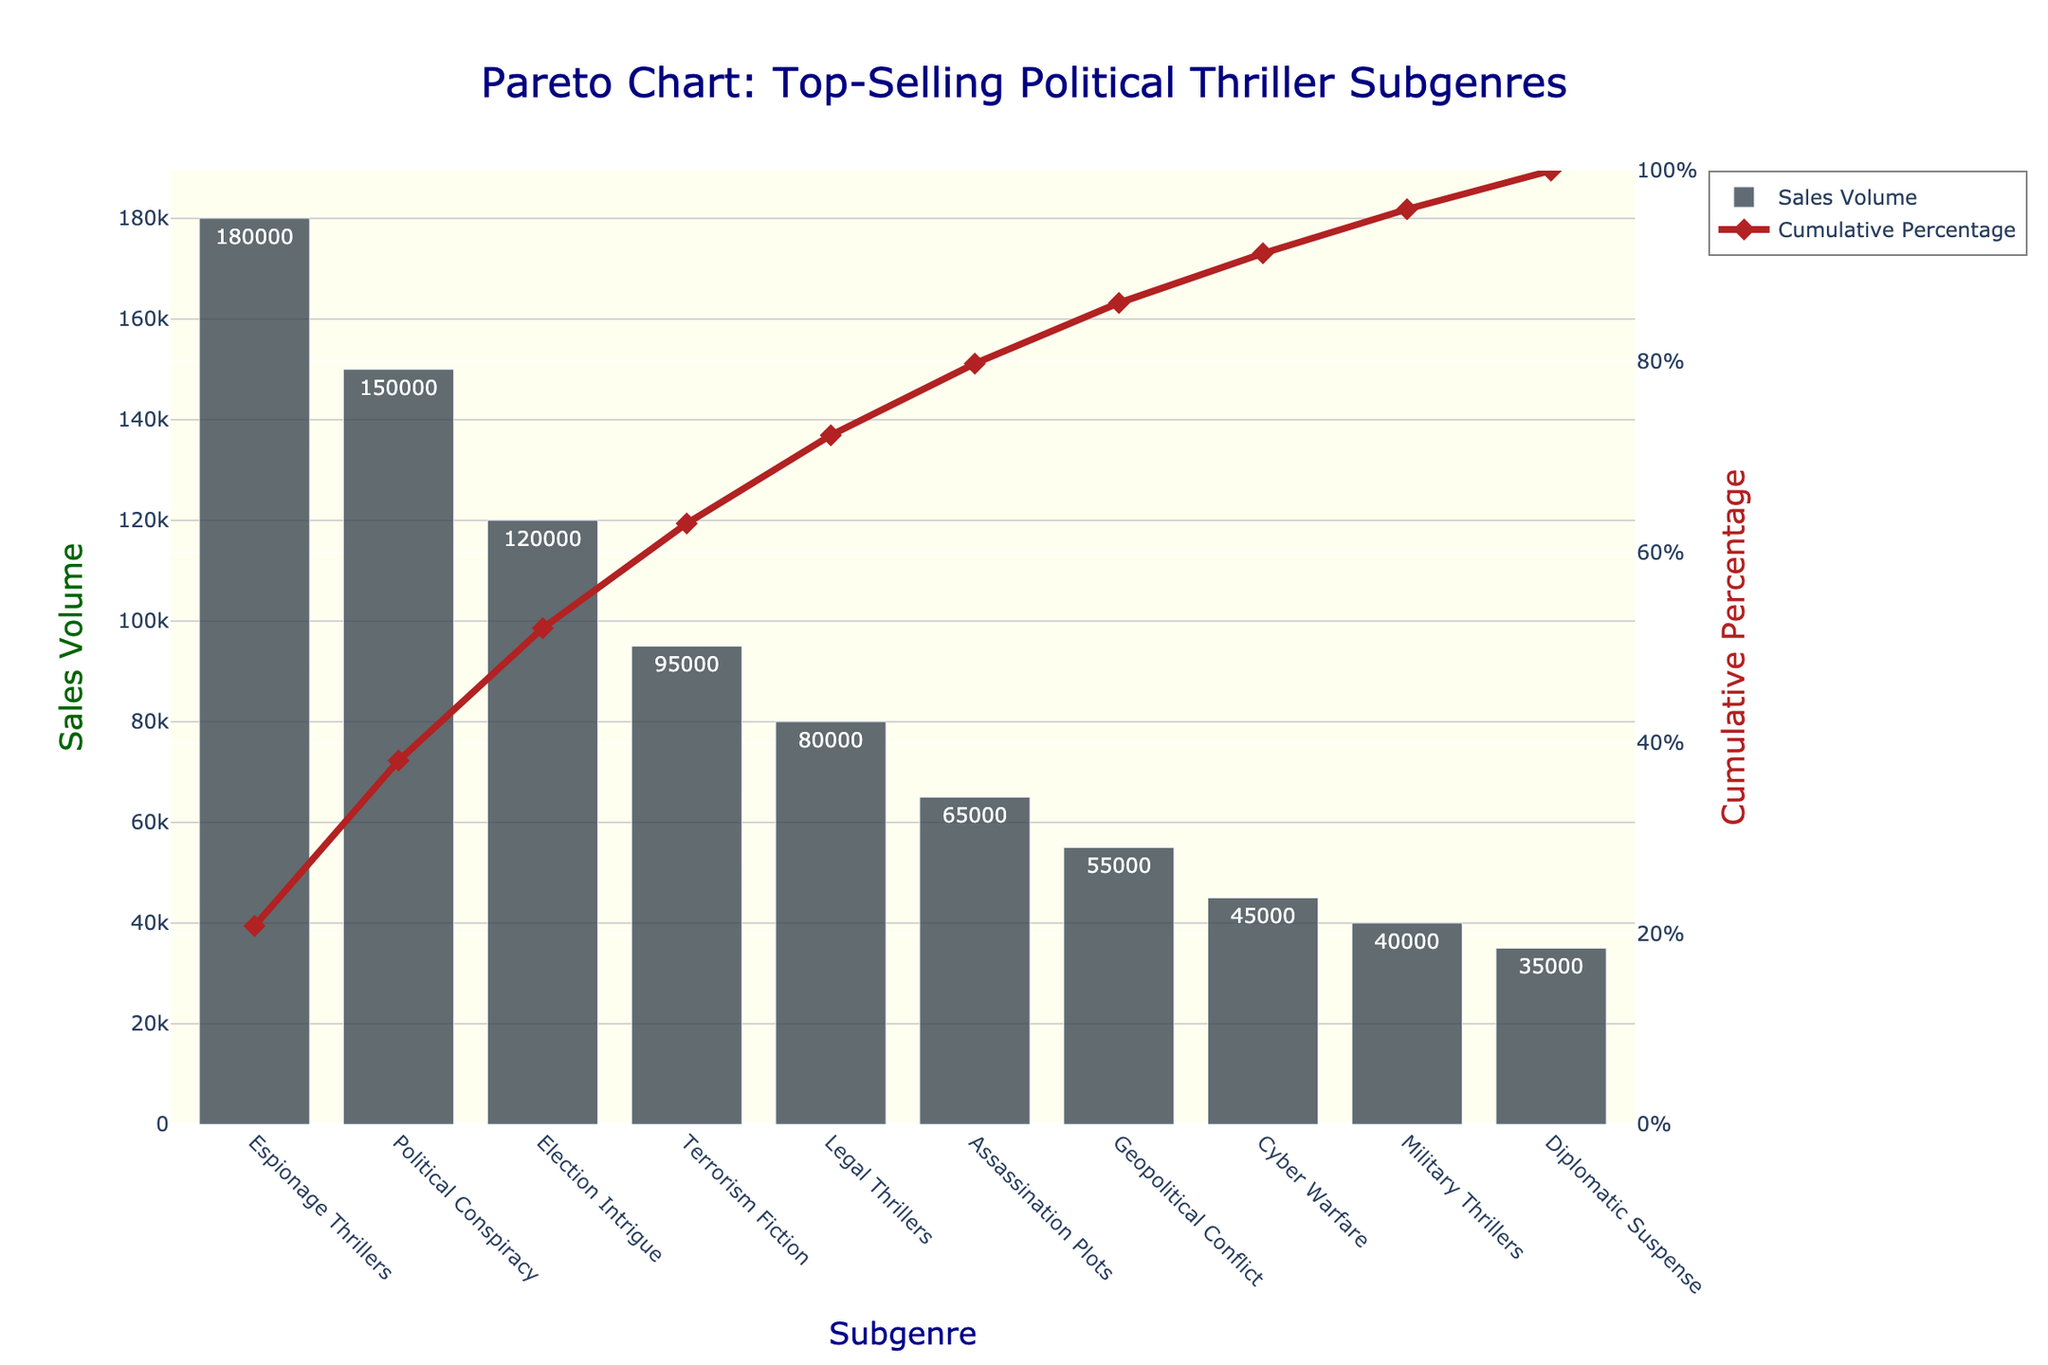What subgenre has the highest sales volume? The subgenre with the highest sales volume is found by looking at the bar with the highest value.
Answer: Espionage Thrillers What is the title of the chart? The title is located at the top of the chart.
Answer: Pareto Chart: Top-Selling Political Thriller Subgenres Which subgenre has the lowest sales volume? The subgenre with the lowest sales volume is found by looking at the bar with the smallest value.
Answer: Diplomatic Suspense What is the cumulative percentage for 'Terrorism Fiction'? Find the line point corresponding to 'Terrorism Fiction' and read the cumulative percentage value on the y-axis on the right.
Answer: 65.0% How many subgenres have a cumulative percentage higher than 50%? Find the point on the line where the cumulative percentage exceeds 50%, and count the subgenres listed before this point.
Answer: 4 What is the sales volume difference between 'Legal Thrillers' and 'Military Thrillers'? Find the sales volumes of 'Legal Thrillers' and 'Military Thrillers', then subtract the latter from the former (80000 - 40000).
Answer: 40000 Which subgenre shows a cumulative percentage closest to 75%? Inspect the cumulative percentage line and find the point closest to the 75%.
Answer: Legal Thrillers How much more did 'Espionage Thrillers' sell compared to 'Cyber Warfare'? Find the sales volumes and subtract 'Cyber Warfare' from 'Espionage Thrillers' (180000 - 45000).
Answer: 135000 What is the cumulative percentage after three subgenres? Add the cumulative percentages from the first three bars.
Answer: 77.5% What color represents the bars in the chart? The color of the bars can be identified by observing their appearance.
Answer: Dark grayish blue 